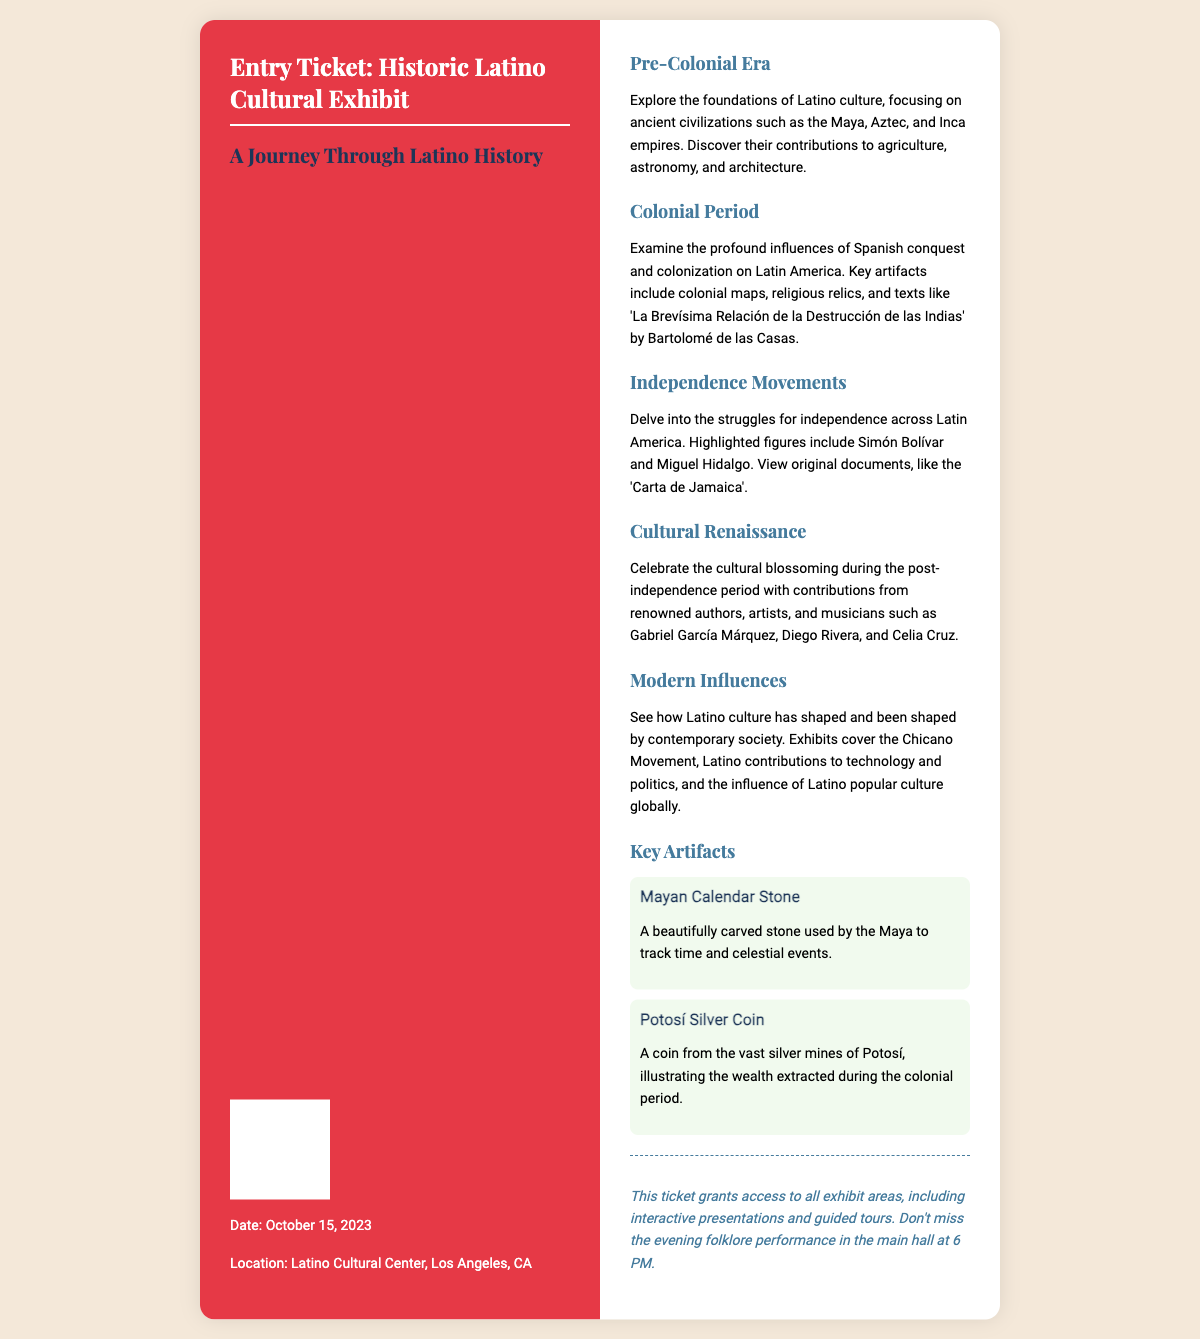What is the title of the exhibit? The title of the exhibit is presented at the top of the ticket.
Answer: Entry Ticket: Historic Latino Cultural Exhibit What is the date of the event? The date is listed in the ticket information section.
Answer: October 15, 2023 Where is the exhibit located? The location is specified in the ticket information.
Answer: Latino Cultural Center, Los Angeles, CA Who are some key figures in the Independence Movements section? The document highlights notable individuals involved in the independence efforts.
Answer: Simón Bolívar and Miguel Hidalgo What is one of the key artifacts displayed in the exhibit? The artifacts section lists significant items that represent Latino culture.
Answer: Mayan Calendar Stone What type of performance is scheduled for the evening? The ticket mentions a specific event happening in the main hall.
Answer: Folklore performance Which ancient civilizations are mentioned in the Pre-Colonial Era section? The section details significant cultures from the era.
Answer: Maya, Aztec, and Inca empires What role did Celia Cruz play in the Cultural Renaissance? The document describes her contribution to the cultural period following independence.
Answer: Musician How many sections are there in the exhibit? The document lists different areas of focus within the exhibit layout.
Answer: Five 